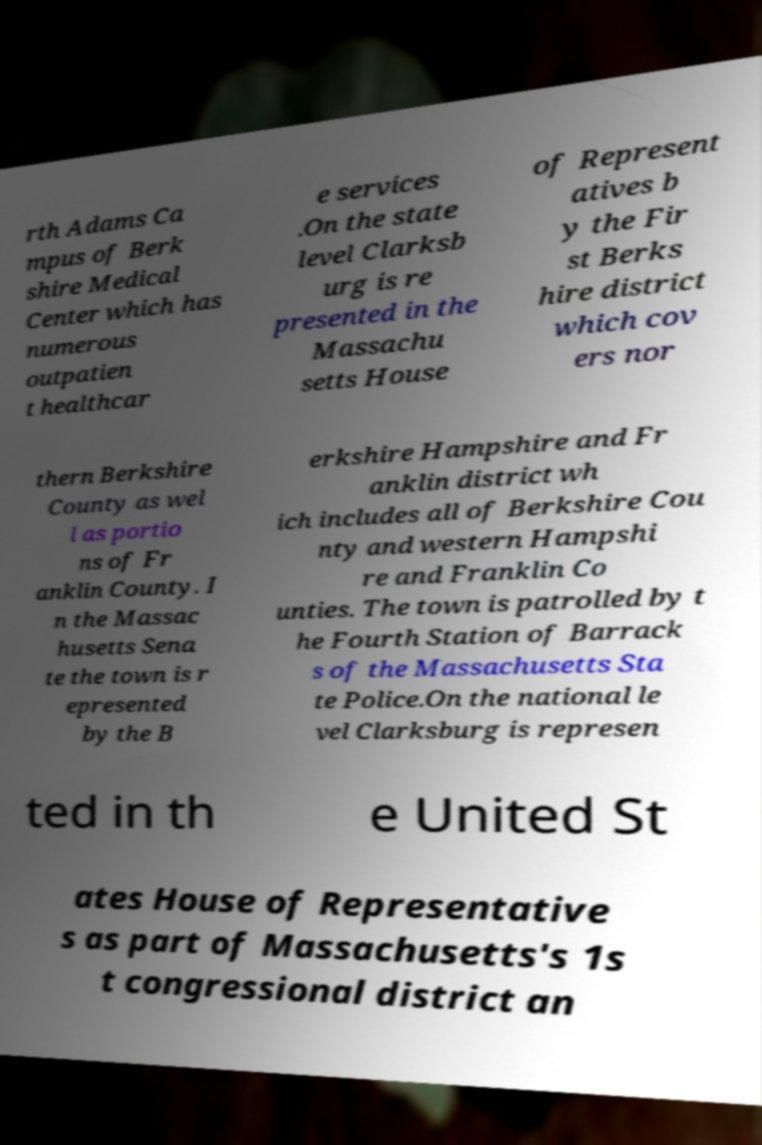Can you accurately transcribe the text from the provided image for me? rth Adams Ca mpus of Berk shire Medical Center which has numerous outpatien t healthcar e services .On the state level Clarksb urg is re presented in the Massachu setts House of Represent atives b y the Fir st Berks hire district which cov ers nor thern Berkshire County as wel l as portio ns of Fr anklin County. I n the Massac husetts Sena te the town is r epresented by the B erkshire Hampshire and Fr anklin district wh ich includes all of Berkshire Cou nty and western Hampshi re and Franklin Co unties. The town is patrolled by t he Fourth Station of Barrack s of the Massachusetts Sta te Police.On the national le vel Clarksburg is represen ted in th e United St ates House of Representative s as part of Massachusetts's 1s t congressional district an 